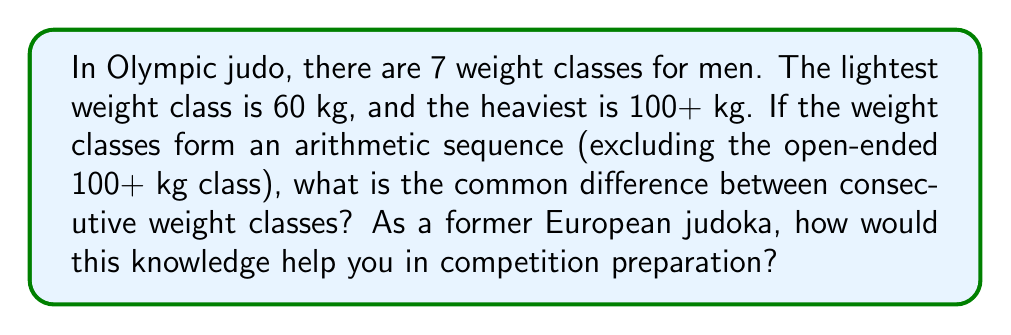Help me with this question. Let's approach this step-by-step:

1) We know that an arithmetic sequence has a constant difference between consecutive terms.

2) We have 7 weight classes, but the last one (100+ kg) doesn't fit into the arithmetic sequence. So we'll consider 6 classes for our calculation.

3) Let's denote the common difference as $d$.

4) The arithmetic sequence formula is:

   $a_n = a_1 + (n-1)d$

   where $a_n$ is the nth term, $a_1$ is the first term, n is the position of the term, and d is the common difference.

5) We know:
   $a_1 = 60$ (the lightest weight class)
   $a_6 = 100$ (the heaviest weight class before the open-ended class)
   $n = 6$ (we're looking at the 6th term)

6) Substituting into the formula:

   $100 = 60 + (6-1)d$
   $100 = 60 + 5d$

7) Solving for $d$:

   $40 = 5d$
   $d = 8$

8) As a former European judoka, knowing this common difference of 8 kg between weight classes could help in strategic weight management. It allows for informed decisions about which weight class to compete in, based on your current weight and how much you might need to gain or lose to reach the next class.
Answer: $d = 8$ kg 